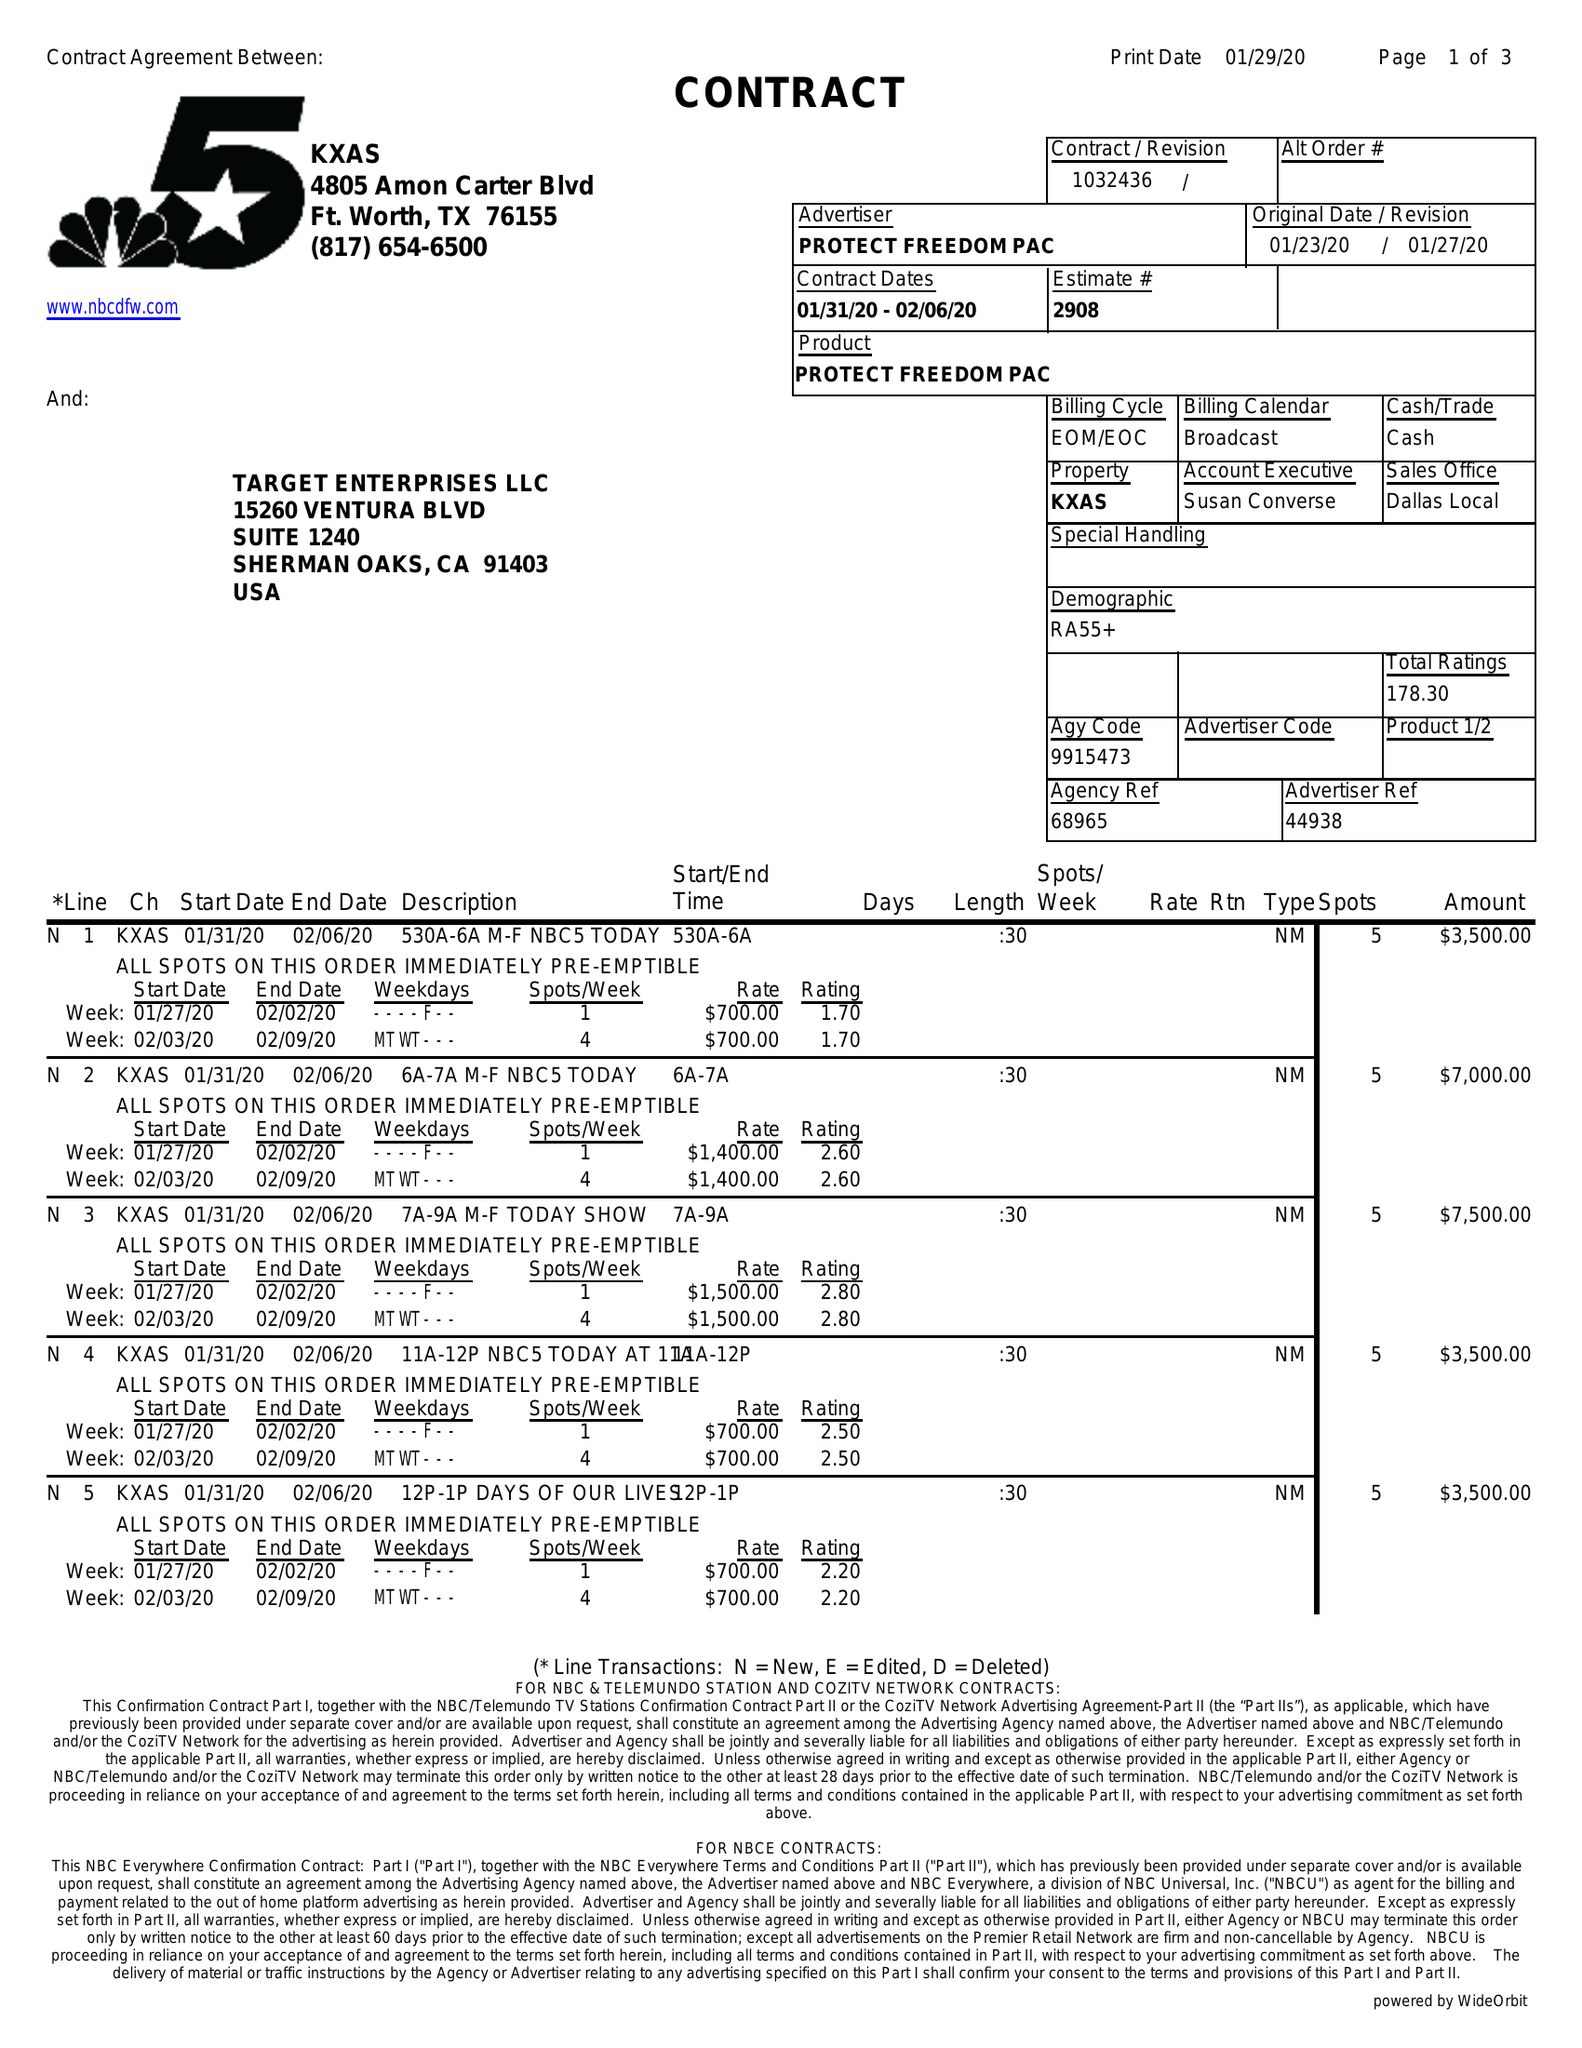What is the value for the contract_num?
Answer the question using a single word or phrase. 1032436 